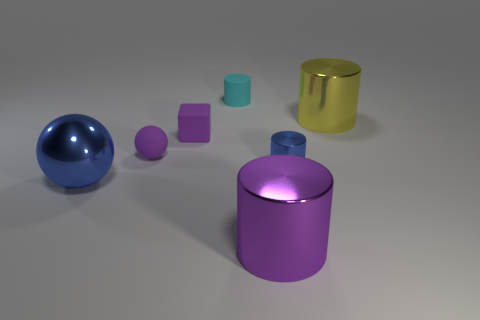Do the big cylinder behind the large purple metal cylinder and the big cylinder in front of the big yellow metal object have the same material?
Keep it short and to the point. Yes. There is another tiny thing that is the same shape as the tiny blue shiny object; what material is it?
Give a very brief answer. Rubber. Is the material of the yellow cylinder the same as the small purple block?
Offer a very short reply. No. What color is the small matte object that is behind the big shiny thing that is on the right side of the large purple metallic cylinder?
Ensure brevity in your answer.  Cyan. The purple cube that is made of the same material as the cyan cylinder is what size?
Keep it short and to the point. Small. How many large gray rubber things are the same shape as the yellow metal thing?
Ensure brevity in your answer.  0. What number of things are either blue objects that are on the right side of the small matte sphere or spheres to the left of the tiny ball?
Your response must be concise. 2. There is a cyan thing to the left of the purple cylinder; what number of tiny matte cubes are to the left of it?
Ensure brevity in your answer.  1. There is a small rubber thing that is behind the yellow cylinder; is it the same shape as the object that is in front of the large ball?
Offer a very short reply. Yes. The metal object that is the same color as the metal sphere is what shape?
Your answer should be very brief. Cylinder. 